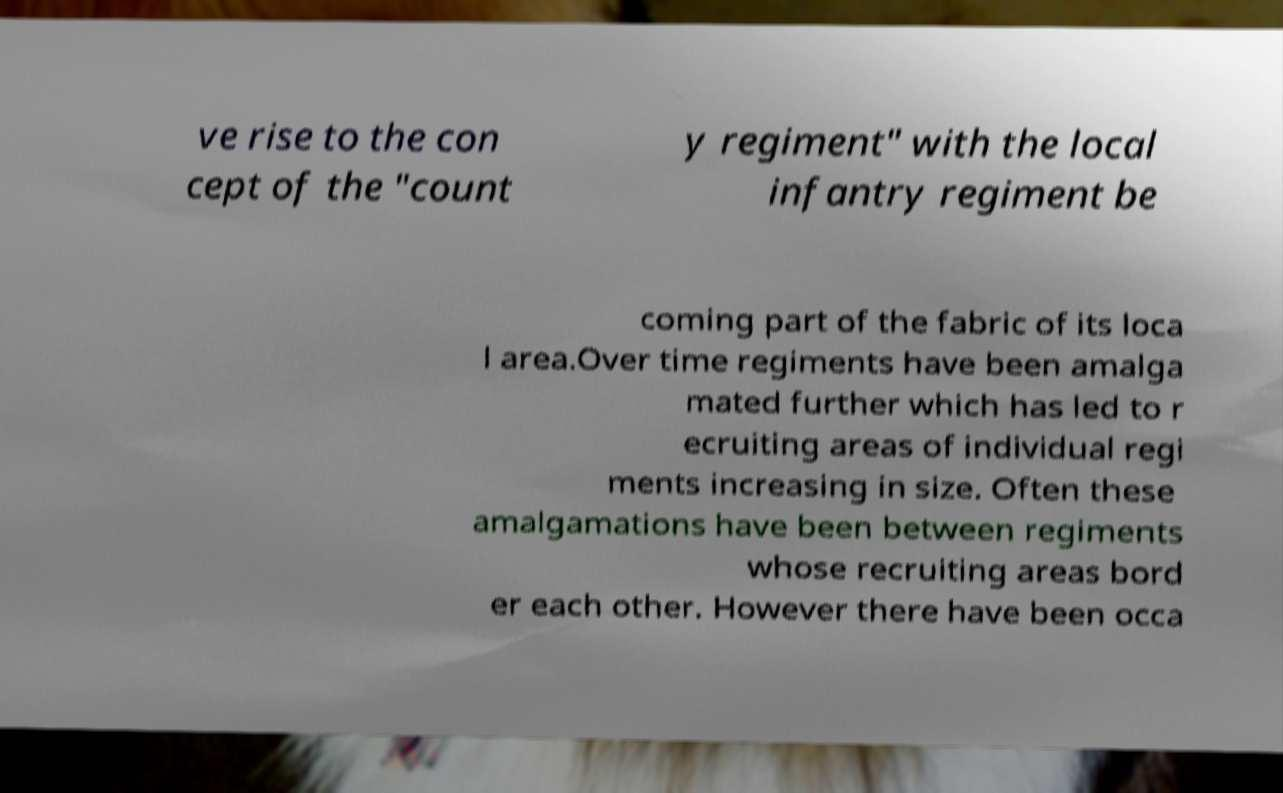Could you extract and type out the text from this image? ve rise to the con cept of the "count y regiment" with the local infantry regiment be coming part of the fabric of its loca l area.Over time regiments have been amalga mated further which has led to r ecruiting areas of individual regi ments increasing in size. Often these amalgamations have been between regiments whose recruiting areas bord er each other. However there have been occa 